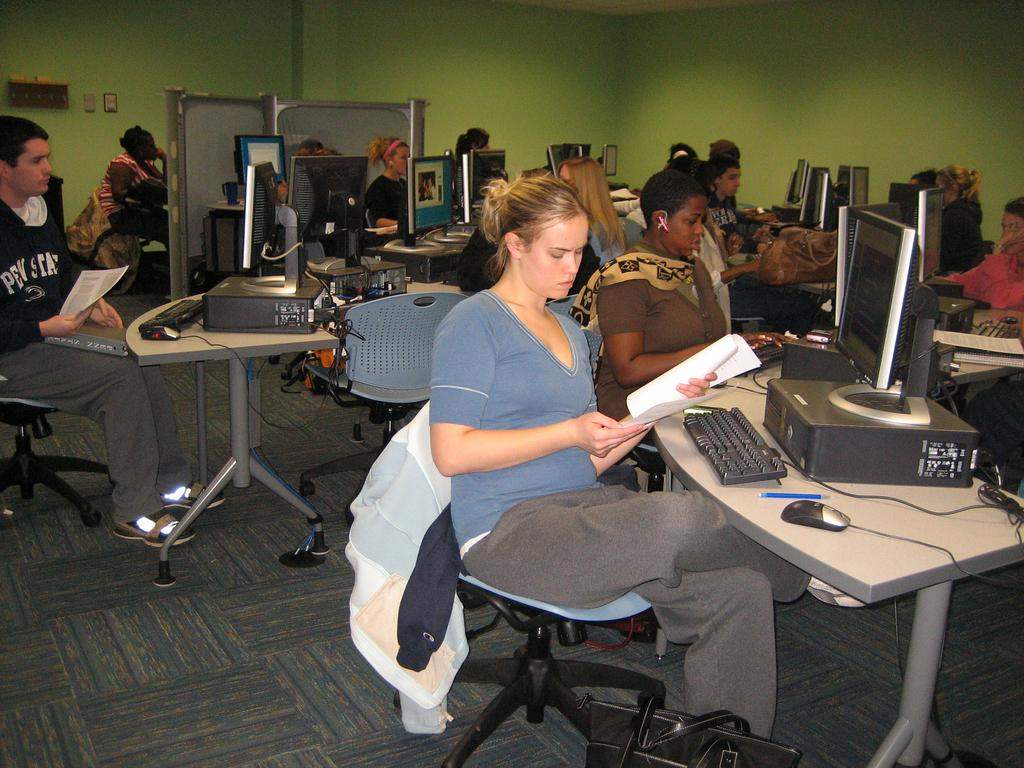What is happening in the image? There is a group of people in the image, and they are sitting in front of a system. What are two people in the image holding? Two people in the image are holding papers. What type of bedroom furniture can be seen in the image? There is no bedroom furniture present in the image; it features a group of people sitting in front of a system. What unit of measurement is being used to determine the size of the act in the image? There is no act or unit of measurement present in the image. 